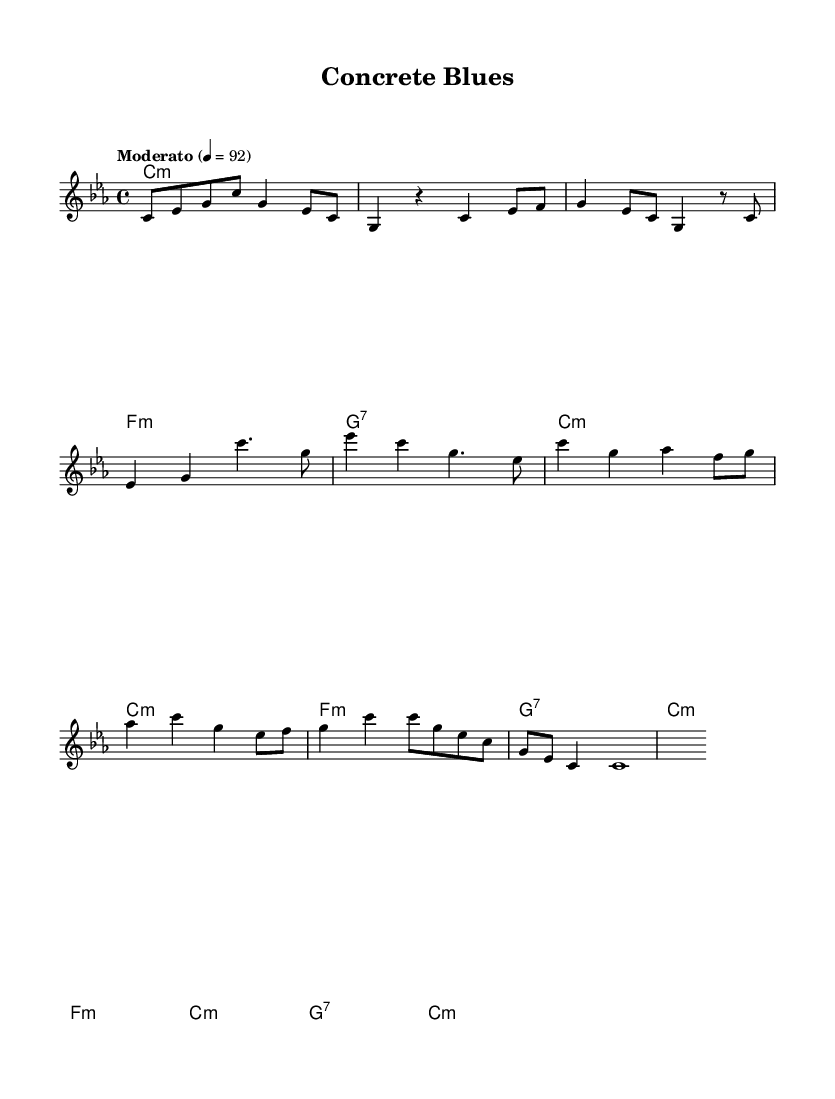What is the key signature of this music? The key signature is C minor, as indicated by the presence of three flats (B♭, E♭, and A♭) in the scale.
Answer: C minor What is the time signature of this piece? The time signature is 4/4, meaning there are four beats in each measure, and a quarter note receives one beat. This is found at the beginning of the score in the time signature markings.
Answer: 4/4 What is the tempo marking indicated in the sheet music? The tempo marking is "Moderato," which indicates a moderate speed. This marking is commonly found near the top of the score, alongside the tempo number indicating beats per minute.
Answer: Moderato How many measures are in the verse section? The verse section consists of two measures as indicated by the layout of the music, with each section typically corresponding to a set of musical phrases.
Answer: 2 How many chords are used in the chorus? The chorus features four distinct chords, which can be identified in the chord changes section corresponding to the lyrics and melody, each aligned with the measures.
Answer: 4 What is the last note of the melody? The last note of the melody is a whole note, which indicates that it should be held for four beats in measure. It is common to see a whole note at the end of a musical piece to signify closure.
Answer: C Which musical mode is primarily used in this composition? The composition primarily uses the minor mode as indicated by the chord structures throughout the piece, with minor chords serving as the foundation for the harmony.
Answer: Minor 